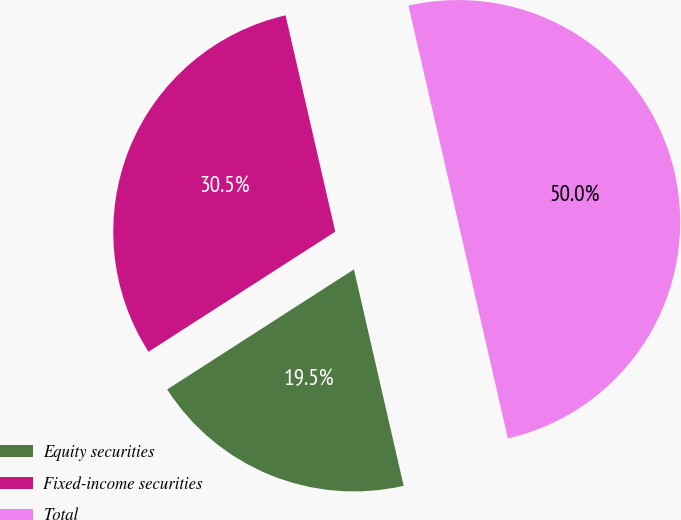<chart> <loc_0><loc_0><loc_500><loc_500><pie_chart><fcel>Equity securities<fcel>Fixed-income securities<fcel>Total<nl><fcel>19.5%<fcel>30.5%<fcel>50.0%<nl></chart> 